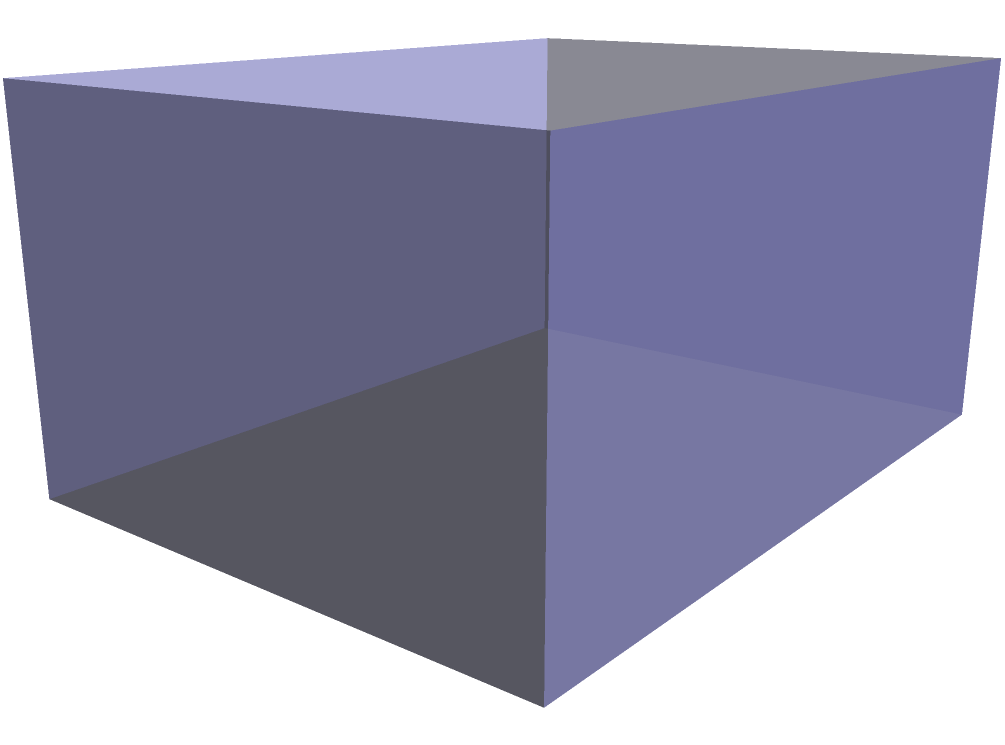Based on the given 2D floor plan, which 3D model accurately represents the sacred structure commonly found in Islamic architecture? To identify the correct 3D model based on the 2D floor plan, we need to analyze the key features:

1. The floor plan shows a rectangular base with dimensions of 4 units by 3 units.
2. There is a circular shape in the center of the rectangle, which likely represents a dome when viewed from above.

Analyzing the 3D model:
1. The base of the 3D model matches the rectangular shape of the floor plan.
2. The walls of the structure are represented by vertical surfaces rising from the base.
3. The most prominent feature is the dome centered on top of the rectangular base.

This 3D model represents a typical mosque design with a central dome, which is a common sacred structure in Islamic architecture. The circular shape in the floor plan corresponds to the projection of the dome onto the ground plane.

In Islamic architectural studies, this type of structure is often associated with congregational mosques, where the central dome typically covers the main prayer hall. The rectangular base represents the overall footprint of the building, which often includes additional spaces for ablutions, education, or community gatherings.

Understanding these architectural elements is crucial for a social anthropologist studying the role of religion in non-democratic societies, as the design of religious buildings often reflects cultural values, social hierarchies, and the relationship between spiritual and temporal power.
Answer: Mosque with central dome 